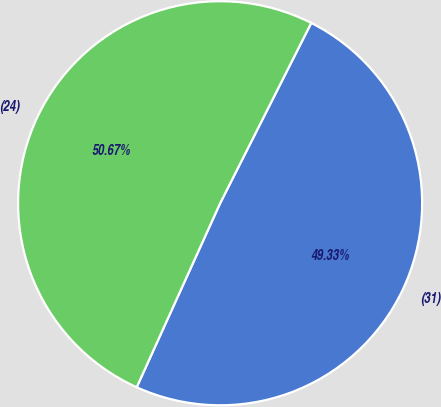Convert chart to OTSL. <chart><loc_0><loc_0><loc_500><loc_500><pie_chart><fcel>(31)<fcel>(24)<nl><fcel>49.33%<fcel>50.67%<nl></chart> 